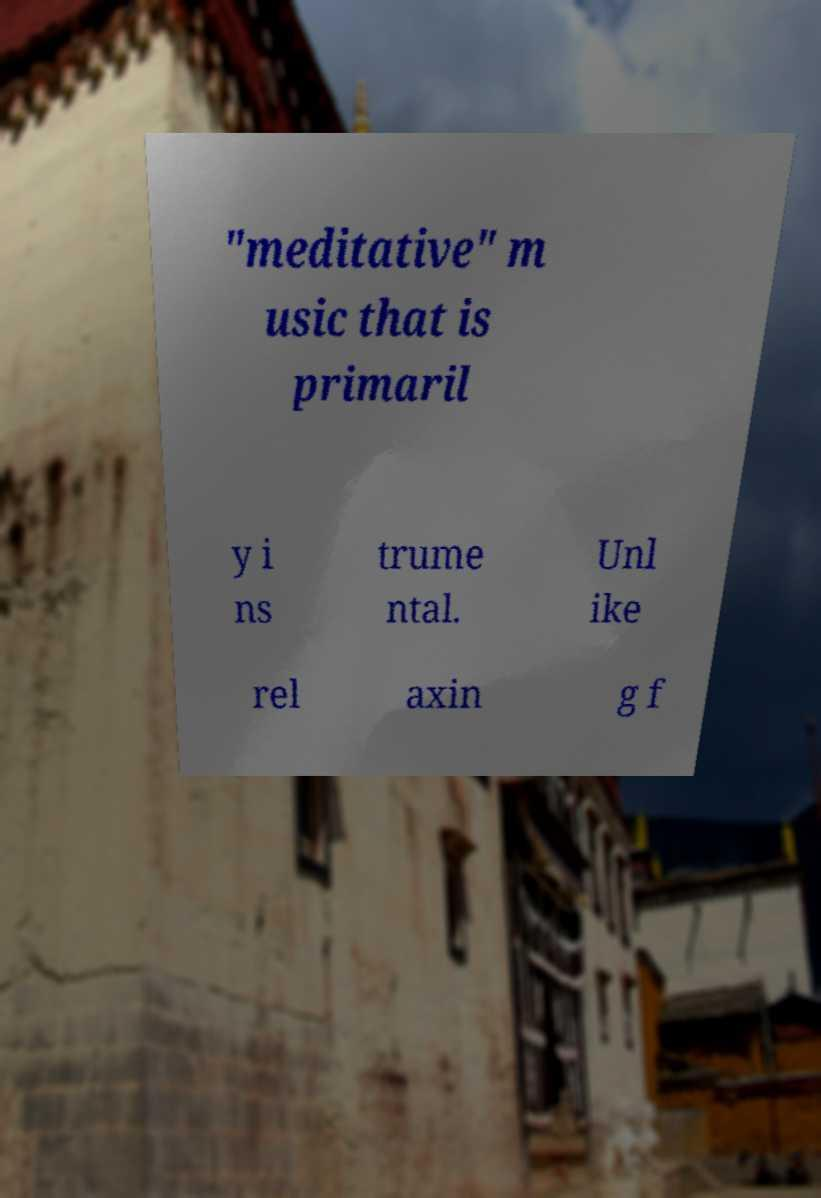Can you read and provide the text displayed in the image?This photo seems to have some interesting text. Can you extract and type it out for me? "meditative" m usic that is primaril y i ns trume ntal. Unl ike rel axin g f 